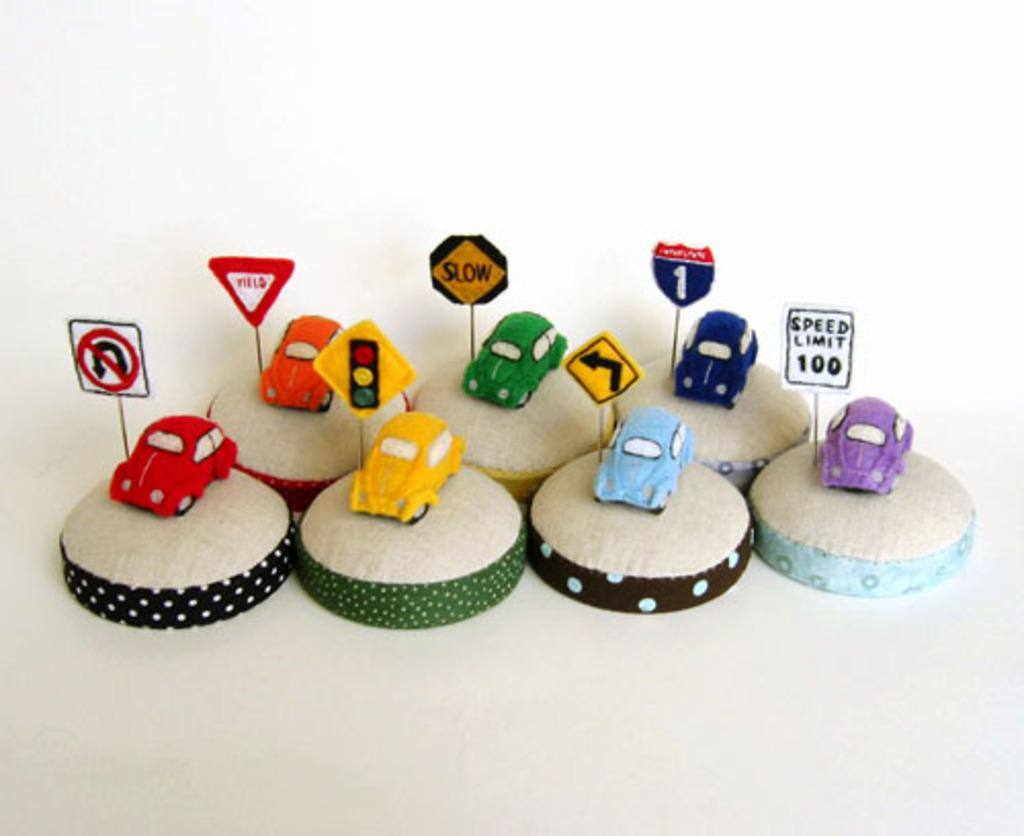What type of toys are present in the image? There are toy cars in the image. How are the toy cars positioned in the image? The toy cars are on mini cushions. What other objects related to transportation can be seen in the image? There are signal lights in the image. What type of signs are present in the image? There are sign boards in the image. What is the caption written on the toy cars in the image? There is no caption written on the toy cars in the image. How does the person in the image slip on the floor? There is no person present in the image, so it is not possible to determine if someone slipped on the floor. 